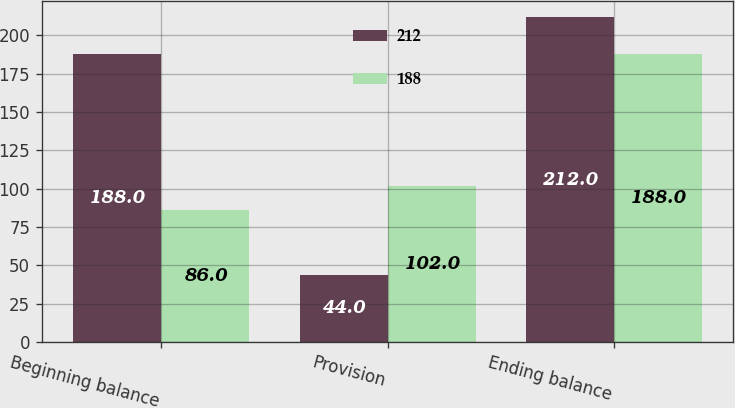<chart> <loc_0><loc_0><loc_500><loc_500><stacked_bar_chart><ecel><fcel>Beginning balance<fcel>Provision<fcel>Ending balance<nl><fcel>212<fcel>188<fcel>44<fcel>212<nl><fcel>188<fcel>86<fcel>102<fcel>188<nl></chart> 